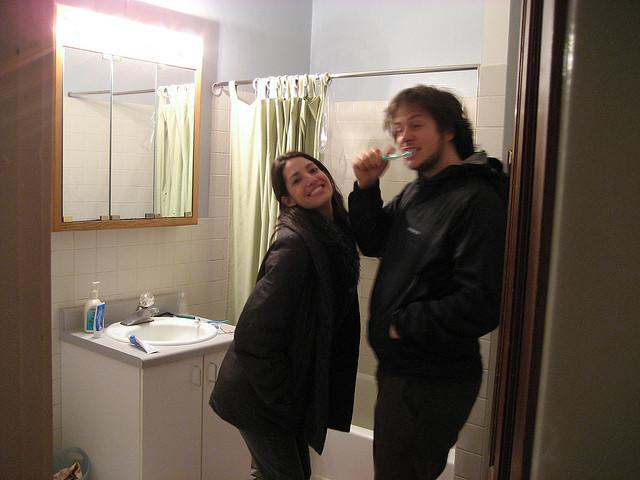Is he brushing his teeth?
Write a very short answer. Yes. Does the bathroom have a bathtub?
Quick response, please. Yes. What is the man wearing?
Short answer required. Jacket. What room of the house is this?
Short answer required. Bathroom. Is the woman in this picture trying to flirt with the man?
Quick response, please. No. 